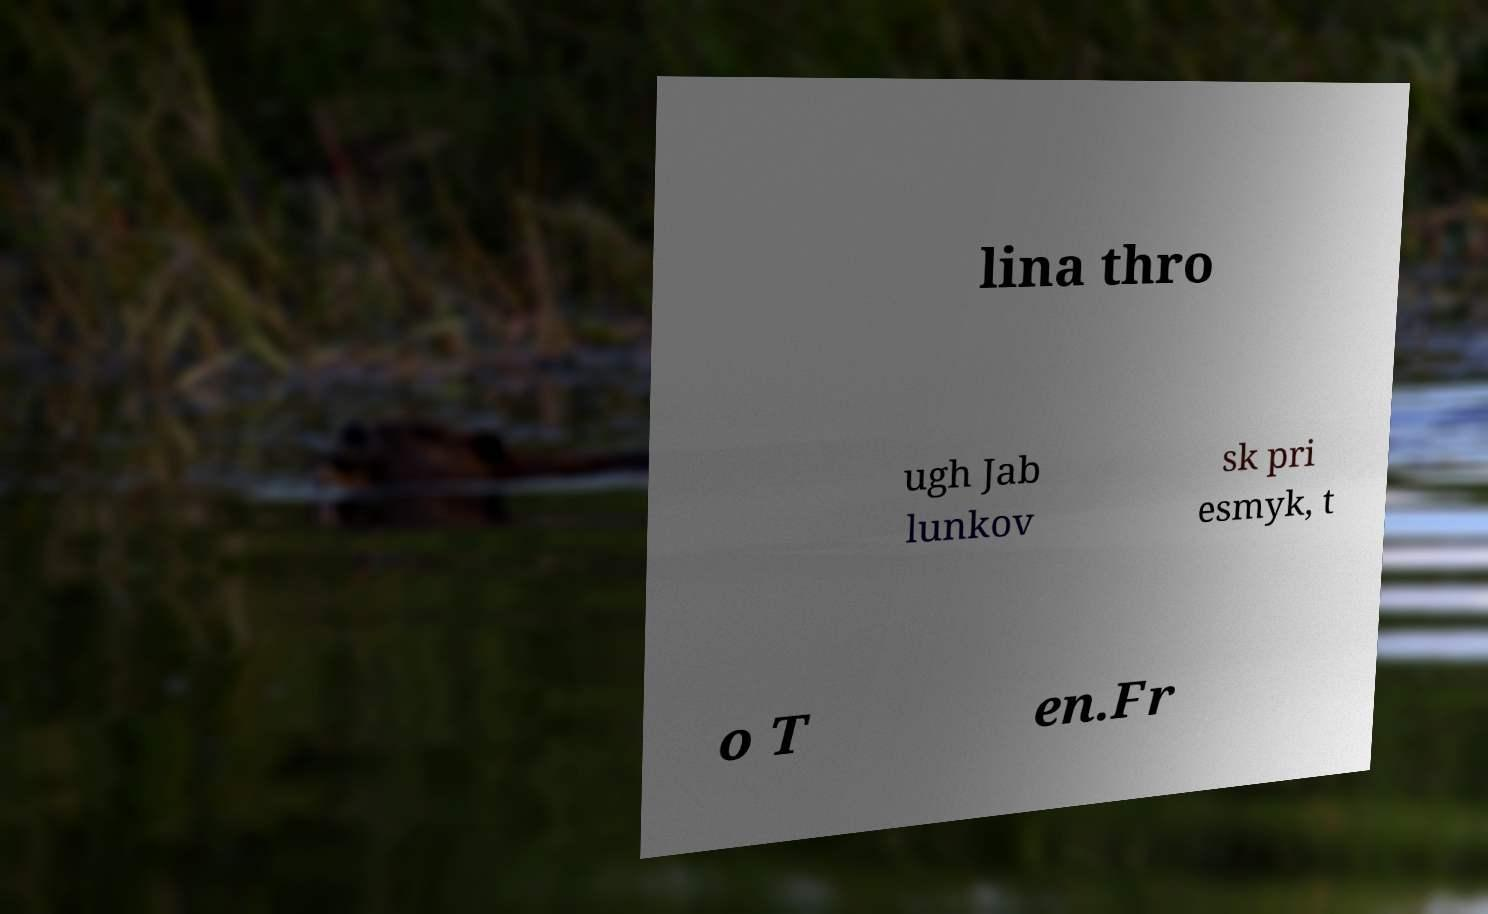I need the written content from this picture converted into text. Can you do that? lina thro ugh Jab lunkov sk pri esmyk, t o T en.Fr 